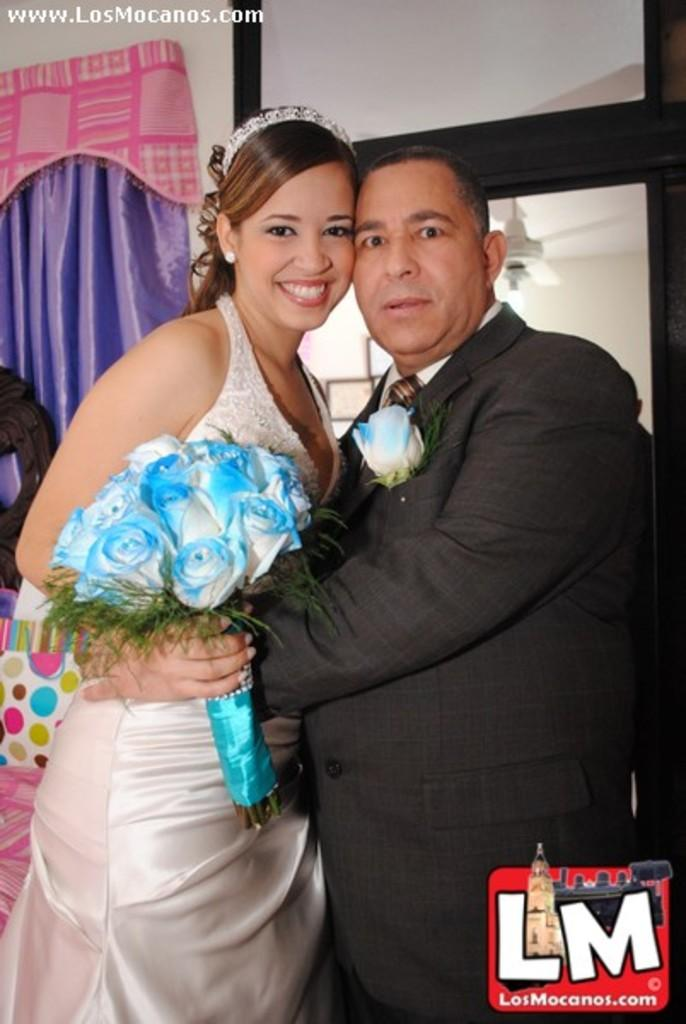How many people are in the image? There are two people in the image. What are the people doing in the image? The people are standing in the image. What colors are the dresses worn by the people? One person is wearing a white dress, and the other is wearing a black dress. What are the people holding in the image? The people are holding a bouquet in the image. What can be seen in the background of the image? There is a purple curtain visible in the background, along with other objects. What hobbies do the sheep in the image enjoy? There are no sheep present in the image, so we cannot determine their hobbies. What type of patch can be seen on the dress of the person in the image? There is no mention of a patch on either dress in the provided facts, so we cannot answer this question. 